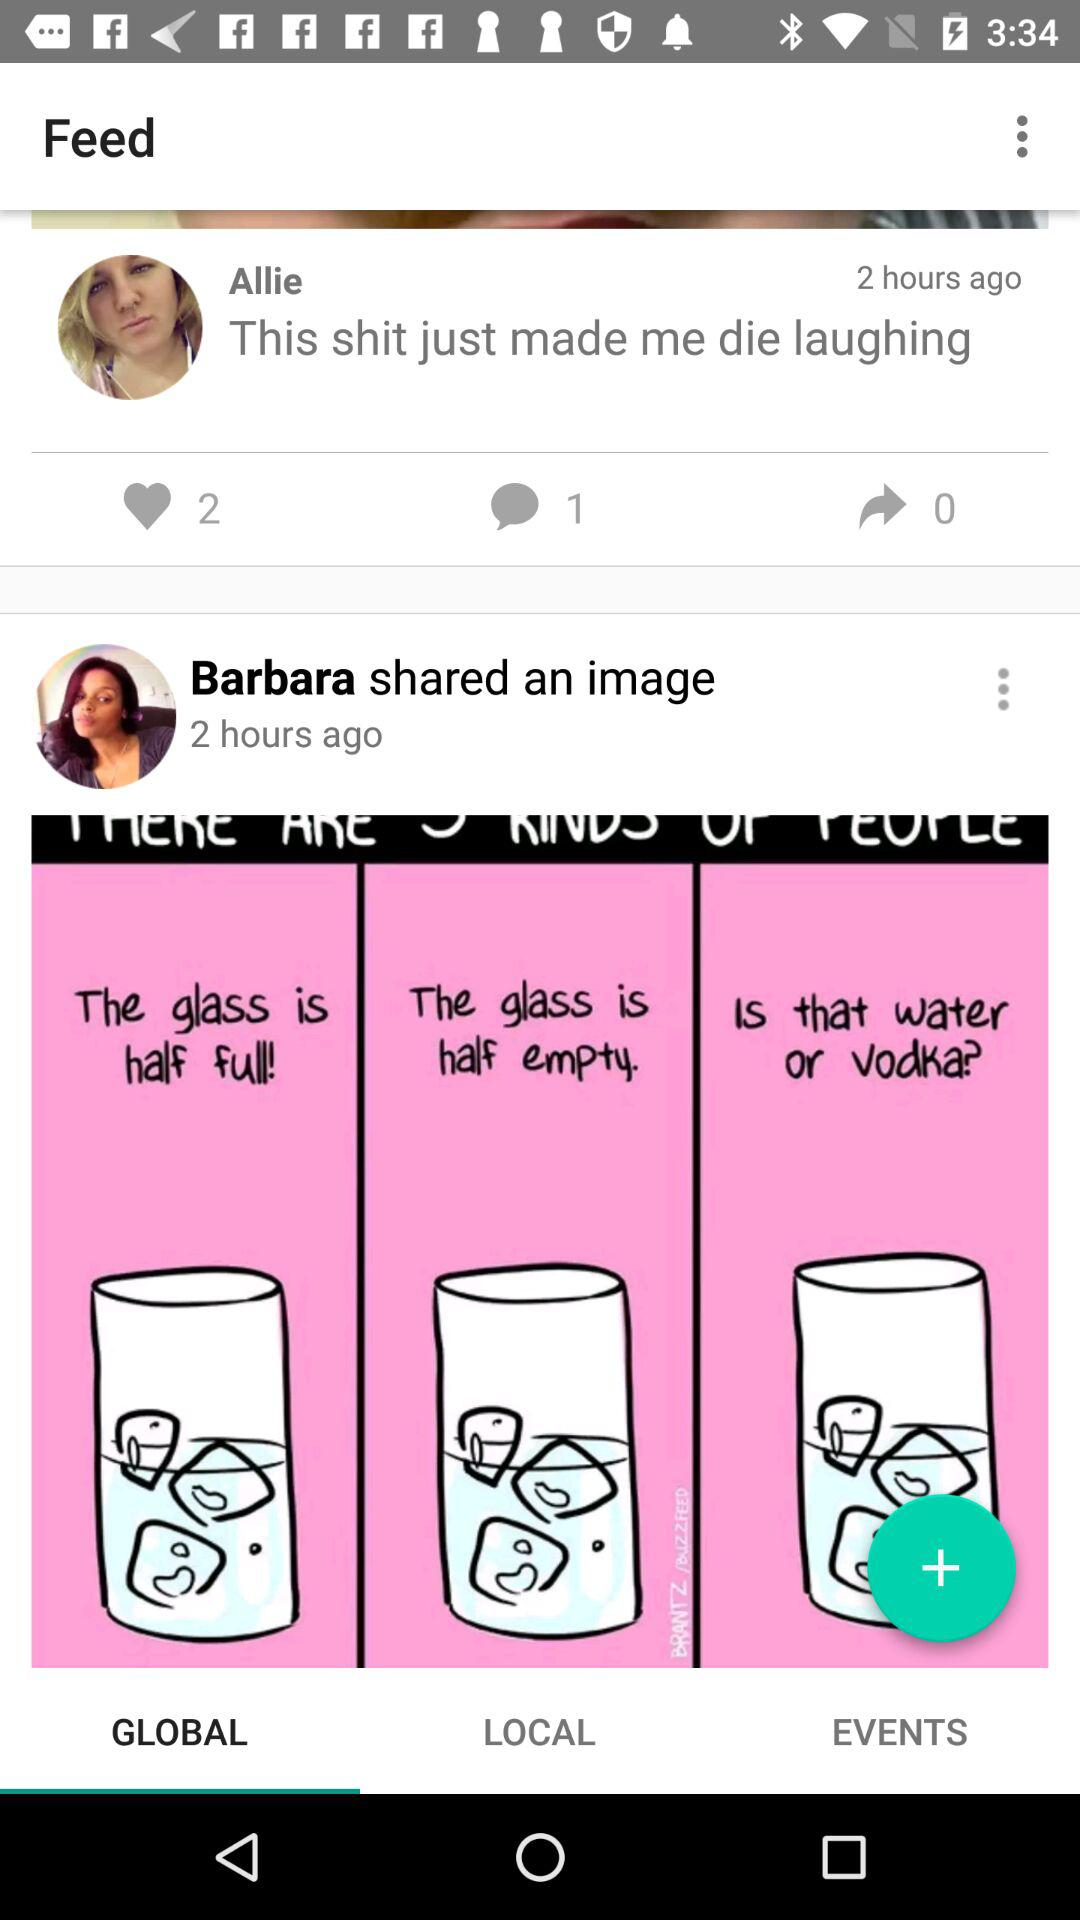How many likes are there on the statement by Allie? There are 2 likes on the statement by Allie. 